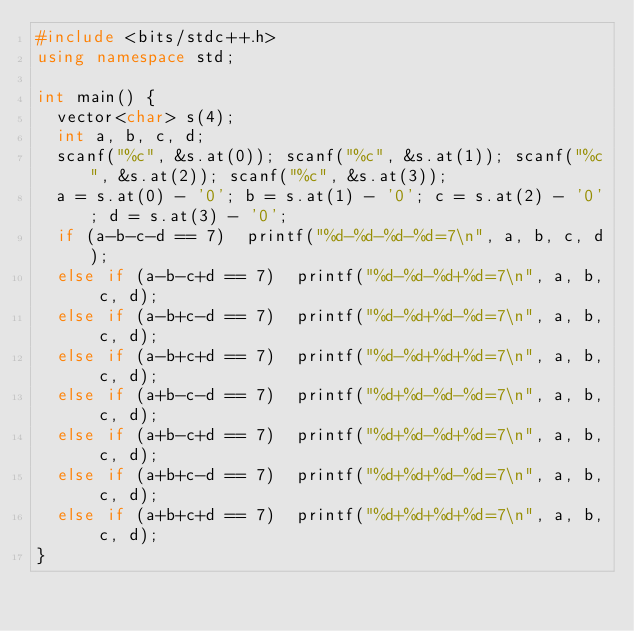Convert code to text. <code><loc_0><loc_0><loc_500><loc_500><_C++_>#include <bits/stdc++.h>
using namespace std;

int main() {
  vector<char> s(4);
  int a, b, c, d;
  scanf("%c", &s.at(0)); scanf("%c", &s.at(1)); scanf("%c", &s.at(2)); scanf("%c", &s.at(3)); 
  a = s.at(0) - '0'; b = s.at(1) - '0'; c = s.at(2) - '0'; d = s.at(3) - '0'; 
  if (a-b-c-d == 7)  printf("%d-%d-%d-%d=7\n", a, b, c, d);
  else if (a-b-c+d == 7)  printf("%d-%d-%d+%d=7\n", a, b, c, d);
  else if (a-b+c-d == 7)  printf("%d-%d+%d-%d=7\n", a, b, c, d);
  else if (a-b+c+d == 7)  printf("%d-%d+%d+%d=7\n", a, b, c, d);
  else if (a+b-c-d == 7)  printf("%d+%d-%d-%d=7\n", a, b, c, d);
  else if (a+b-c+d == 7)  printf("%d+%d-%d+%d=7\n", a, b, c, d);
  else if (a+b+c-d == 7)  printf("%d+%d+%d-%d=7\n", a, b, c, d);
  else if (a+b+c+d == 7)  printf("%d+%d+%d+%d=7\n", a, b, c, d);
}
</code> 